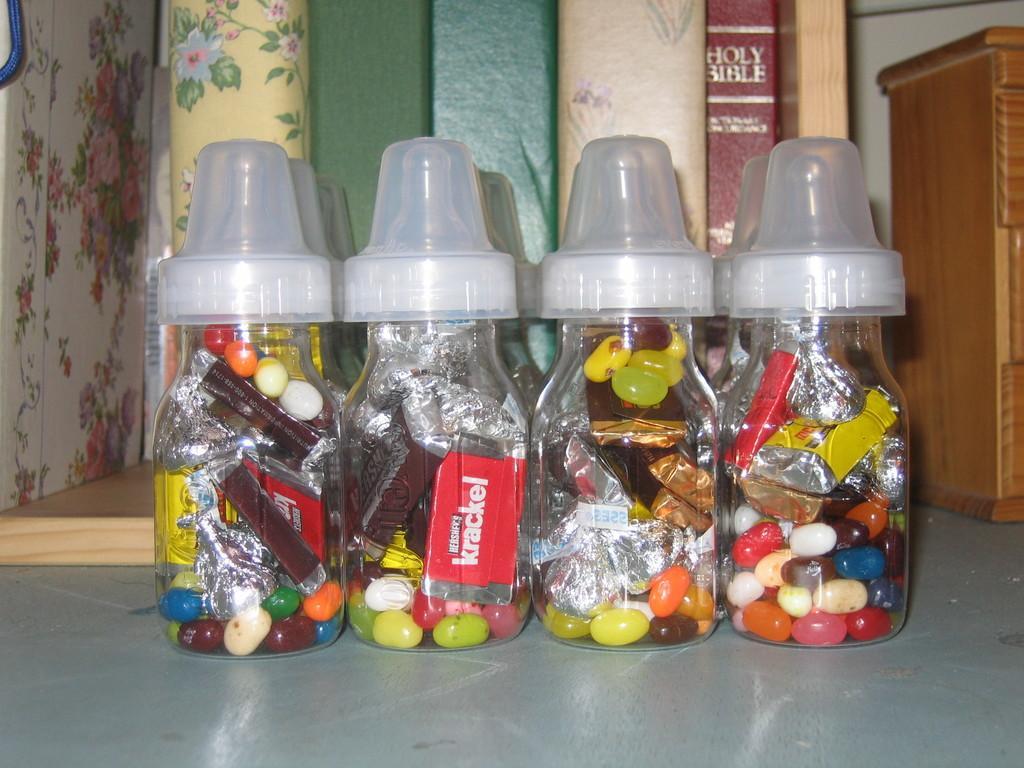Describe this image in one or two sentences. In the image there are four bottles on which it is labelled as 'KRACKEL' which is placed on floor, on right side we can also see a table,books in middle. 